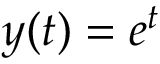Convert formula to latex. <formula><loc_0><loc_0><loc_500><loc_500>y ( t ) = e ^ { t }</formula> 